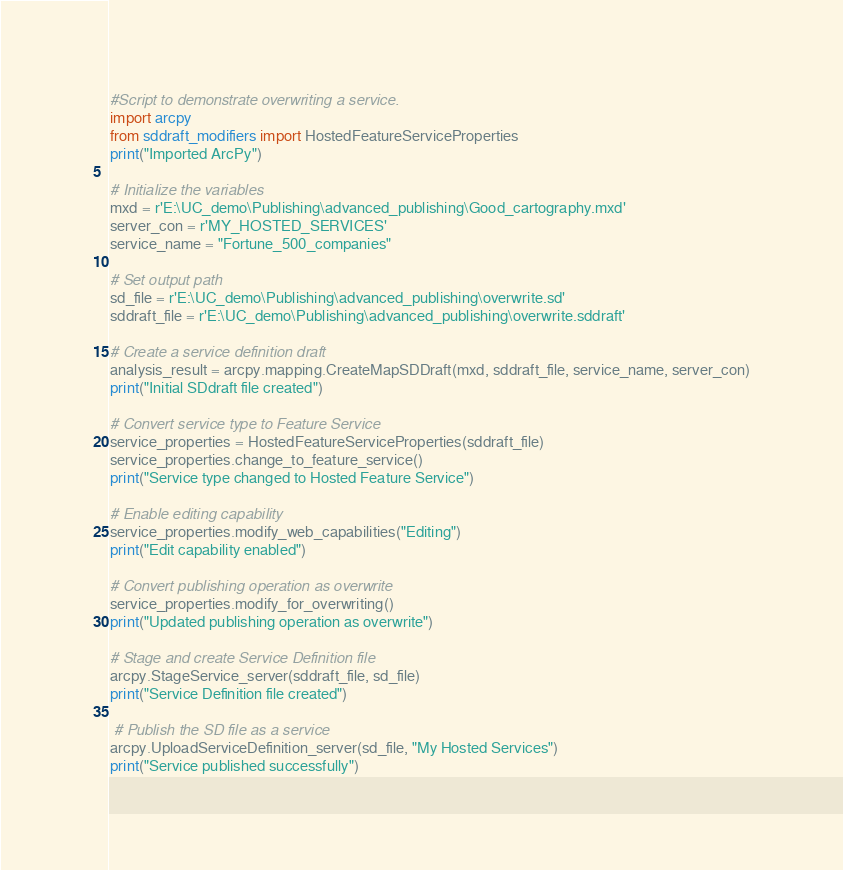Convert code to text. <code><loc_0><loc_0><loc_500><loc_500><_Python_>#Script to demonstrate overwriting a service.
import arcpy
from sddraft_modifiers import HostedFeatureServiceProperties
print("Imported ArcPy")

# Initialize the variables
mxd = r'E:\UC_demo\Publishing\advanced_publishing\Good_cartography.mxd'
server_con = r'MY_HOSTED_SERVICES'
service_name = "Fortune_500_companies"

# Set output path
sd_file = r'E:\UC_demo\Publishing\advanced_publishing\overwrite.sd'
sddraft_file = r'E:\UC_demo\Publishing\advanced_publishing\overwrite.sddraft'

# Create a service definition draft
analysis_result = arcpy.mapping.CreateMapSDDraft(mxd, sddraft_file, service_name, server_con)
print("Initial SDdraft file created")

# Convert service type to Feature Service
service_properties = HostedFeatureServiceProperties(sddraft_file)
service_properties.change_to_feature_service()
print("Service type changed to Hosted Feature Service")

# Enable editing capability
service_properties.modify_web_capabilities("Editing")
print("Edit capability enabled")

# Convert publishing operation as overwrite
service_properties.modify_for_overwriting()
print("Updated publishing operation as overwrite")

# Stage and create Service Definition file
arcpy.StageService_server(sddraft_file, sd_file)
print("Service Definition file created")

 # Publish the SD file as a service
arcpy.UploadServiceDefinition_server(sd_file, "My Hosted Services")
print("Service published successfully")</code> 